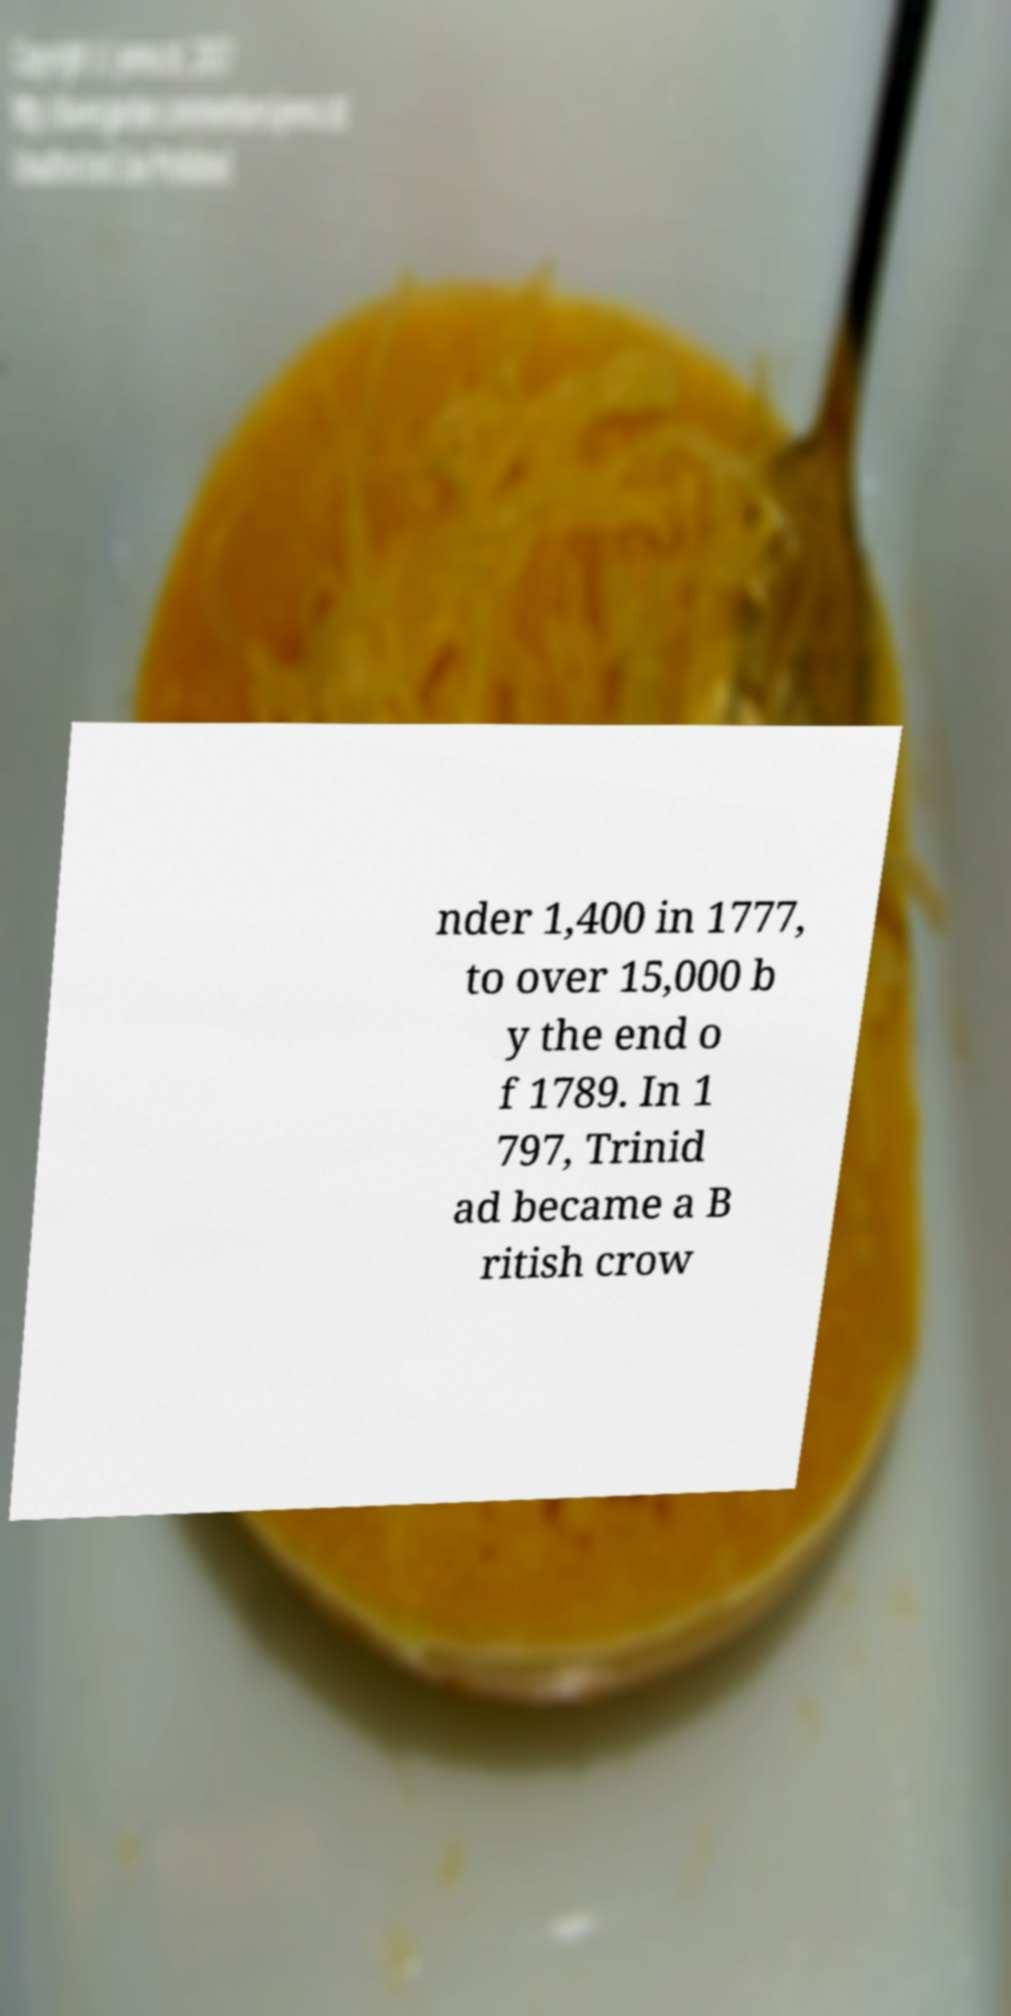Please identify and transcribe the text found in this image. nder 1,400 in 1777, to over 15,000 b y the end o f 1789. In 1 797, Trinid ad became a B ritish crow 